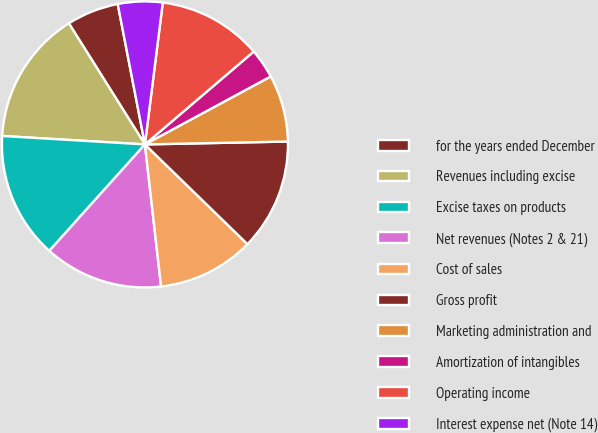Convert chart to OTSL. <chart><loc_0><loc_0><loc_500><loc_500><pie_chart><fcel>for the years ended December<fcel>Revenues including excise<fcel>Excise taxes on products<fcel>Net revenues (Notes 2 & 21)<fcel>Cost of sales<fcel>Gross profit<fcel>Marketing administration and<fcel>Amortization of intangibles<fcel>Operating income<fcel>Interest expense net (Note 14)<nl><fcel>5.88%<fcel>15.13%<fcel>14.29%<fcel>13.45%<fcel>10.92%<fcel>12.6%<fcel>7.56%<fcel>3.36%<fcel>11.76%<fcel>5.04%<nl></chart> 